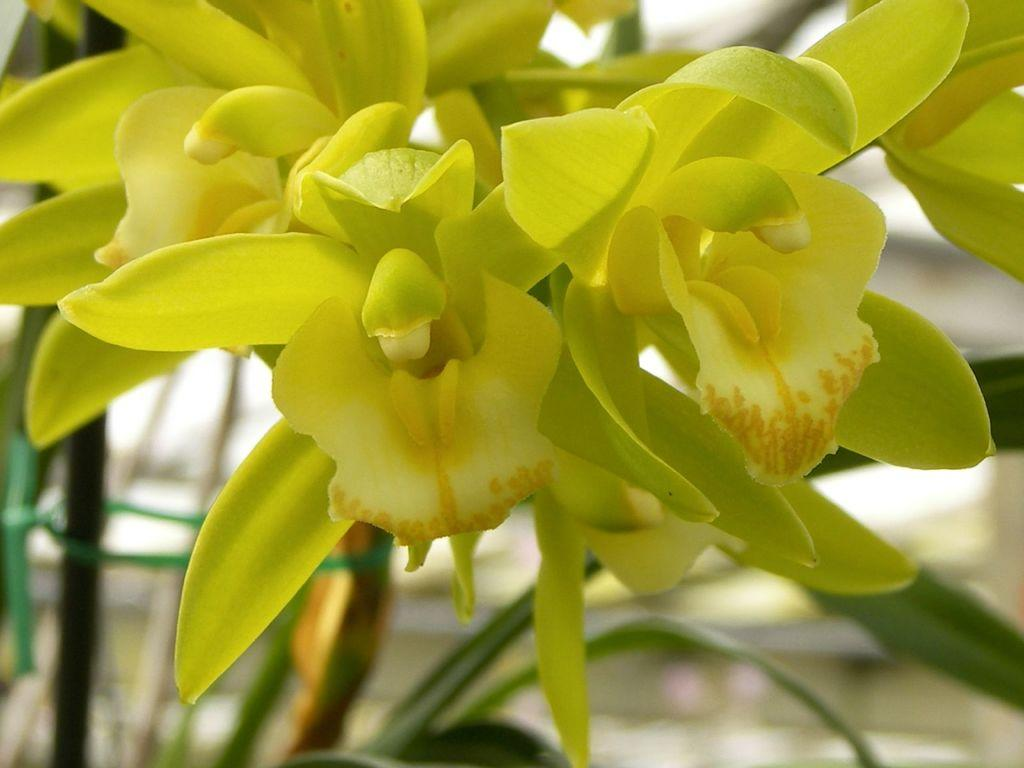What type of plants can be seen in the image? There are flowers in the image. What can be seen in the background of the image? There are leaves and some unspecified objects in the background of the image. How would you describe the clarity of the image? The image is blurry. What type of unit is being used to measure the length of the knife in the image? There is no knife present in the image, so it is not possible to determine what type of unit would be used to measure its length. 